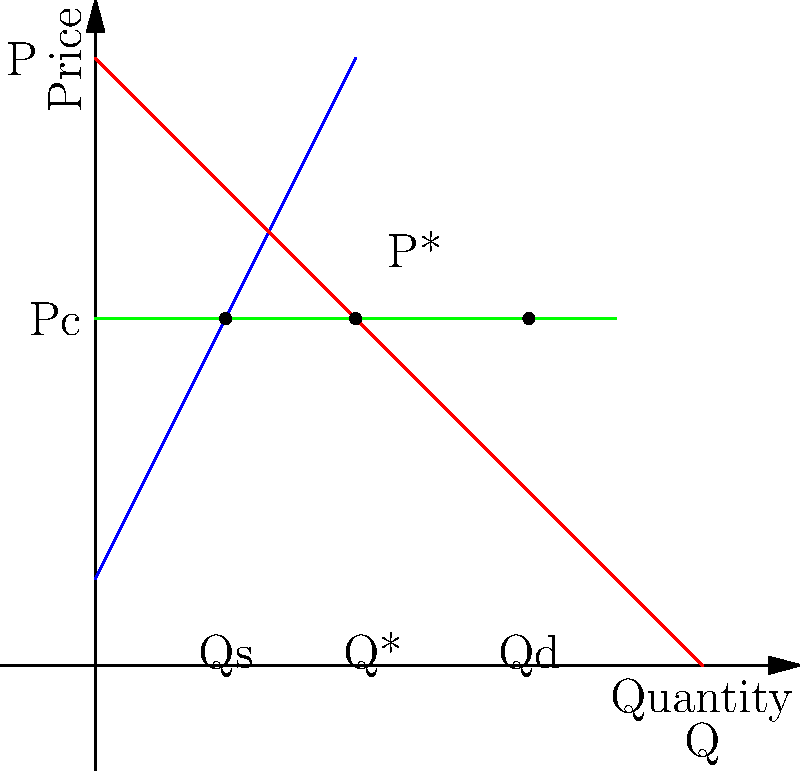The graph shows supply and demand curves for a product, along with a government-imposed price ceiling. How does this price control affect the market equilibrium, and what economic consequences arise from this policy? To analyze the effects of the price ceiling, let's follow these steps:

1. Identify the market equilibrium:
   The equilibrium point (P*, Q*) is where supply and demand curves intersect. This represents the free-market price and quantity.

2. Observe the price ceiling:
   The green horizontal line represents the government-imposed price ceiling (Pc), set below the equilibrium price.

3. Determine the quantity supplied at the price ceiling:
   At Pc, producers are willing to supply Qs, which is less than Q*.

4. Determine the quantity demanded at the price ceiling:
   At Pc, consumers demand Qd, which is greater than Q*.

5. Identify the shortage:
   The difference between Qd and Qs represents the shortage in the market.

6. Economic consequences:
   a) Shortage: Demand exceeds supply at the controlled price.
   b) Inefficient allocation: The price mechanism can't function to clear the market.
   c) Black markets: May emerge as people seek to buy/sell above the legal price.
   d) Reduced product quality: Producers may cut corners to maintain profitability.
   e) Rationing: Non-price methods of distribution become necessary.
   f) Deadweight loss: Overall economic efficiency decreases.

7. Long-term effects:
   Producers have less incentive to invest in production, potentially leading to even greater shortages over time.
Answer: Creates shortage, inefficient allocation, potential black markets, reduced quality, and deadweight loss. 